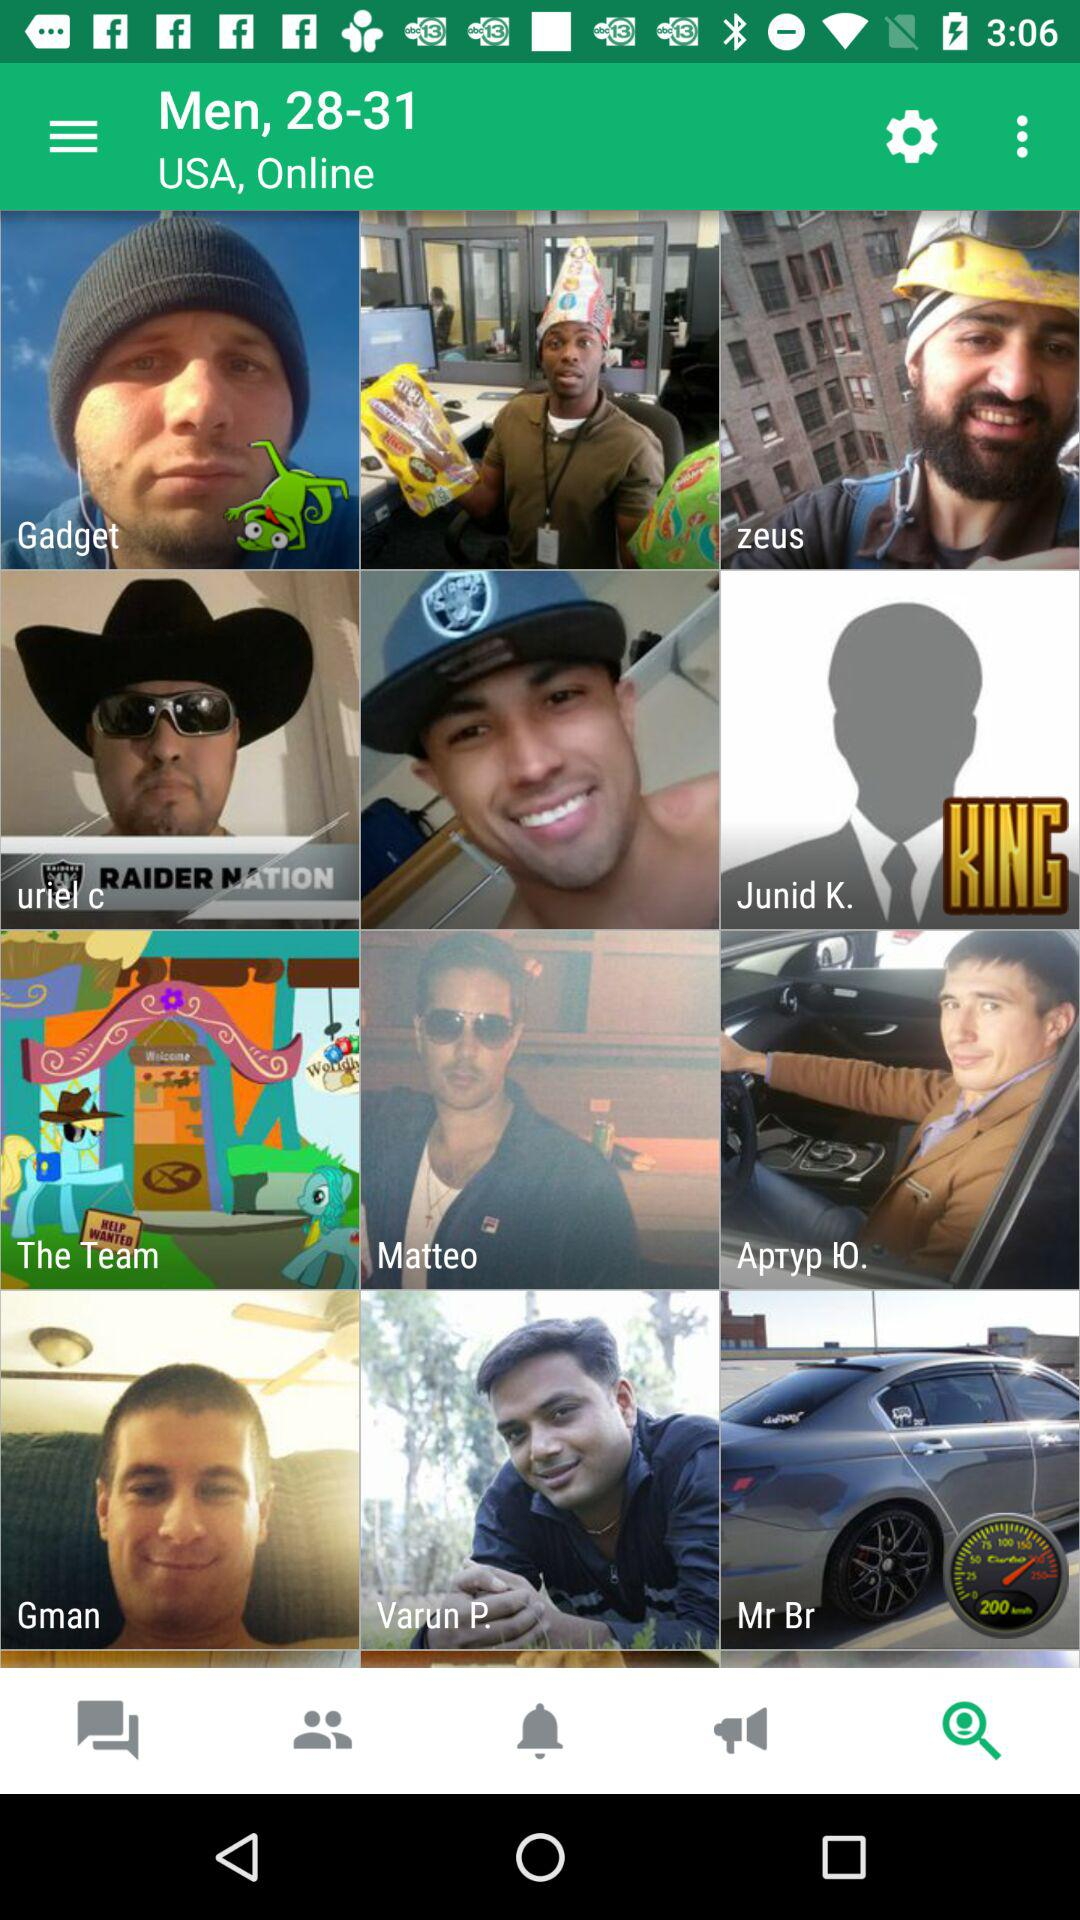Which tab is selected? The selected tab is "Search Profile". 